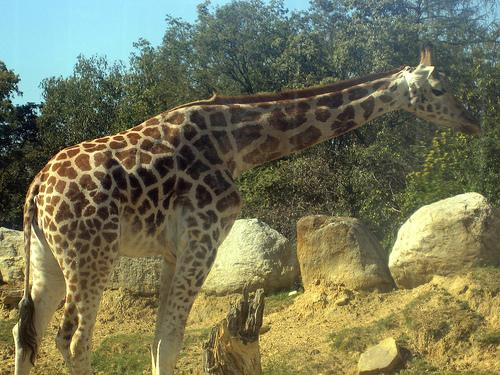Mention the color and location of the sand in the image. The sand is brown and is located at the bottom of the image. List the physical features of the giraffe that are mentioned in the image details. Long neck, spots, furry tail, horns, legs, tail, ear, eye, nose, and main. Explain the context of the image in terms of the subject and its surroundings. The image features a brown and white giraffe out in the wild, surrounded by large rocks, green trees, and a clear blue sky. What is the state and location of the trees in this image? The trees are green, tall, and clumped together. What specific part of the giraffe is facing towards the right side of the image? The giraffe's face is looking to the right. What species is the main focus in this image, and what is its defining feature? The main focus is a giraffe, and its defining feature is its long neck and spots. Identify the most prominent color of the sky in the image. The most prominent color of the sky in the image is blue. Provide a brief description of the terrain on which the giraffe stands. The giraffe is standing on brown ground with green patches of grass and large rocks in the background. What's the setting of the photo, and what is the state of the trees? The photo was taken outdoors, and the trees are green and tall. Describe the position and appearance of the rocks in the image. The rocks are lying on the ground, they are huge, and their color is brown. What objects can be found behind the giraffe? Big rocks Which direction is the giraffe looking towards? To the right What event is occurring in the image? Giraffe standing out in the wild. What is the color of the rocks? Brown Are the rocks in the image purple? The rocks in the image are described as brown and huge, so suggesting they are purple is incorrect and misleading. Are there any trees visible in the image? Yes, there are trees. Write a short sentence to describe the giraffe's neck. The giraffe has a long neck. Is the giraffe's tail short and not furry? The giraffe's tail in the image is described as 'furry' so asking if it's short and not furry is incorrect and misleading. Is the grass in the image blue? The grass in the image is described as green, so suggesting that it is blue is incorrect and misleading. What is the dominant color of the sky in the image?  Blue What type of animal is visible in the image? Giraffe Describe the background of the image. A clear blue sky with green tall trees. How many rocks are lying on the ground? Four What does the text on the image say? There is no text in the image. Is the giraffe indoors or outdoors? Outdoors Which is the correct description of the giraffe's tail: furry or smooth?  Furry Are the trees in the image small and not green? The trees in the image are described as tall and green, so suggesting they are small and not green is incorrect and misleading. Is the photo taken during daytime or nighttime? Daytime Describe the body part of the giraffe with spots. Giraffe's leg What can you infer about the color of the giraffe from the image? The giraffe is brown and white. Can you write a sentence describing the trees in the image? The trees are green and tall. Is the giraffe's skin color pink and without spots? The giraffe in the image is described as brown and white with spots, so suggesting it is pink and without spots is incorrect and misleading. Is the sky in the image red and cloudy? The sky in the image is described as blue and clear, so suggesting it is red and cloudy is incorrect and misleading. What kind of ground in the image? The sand is brown. 